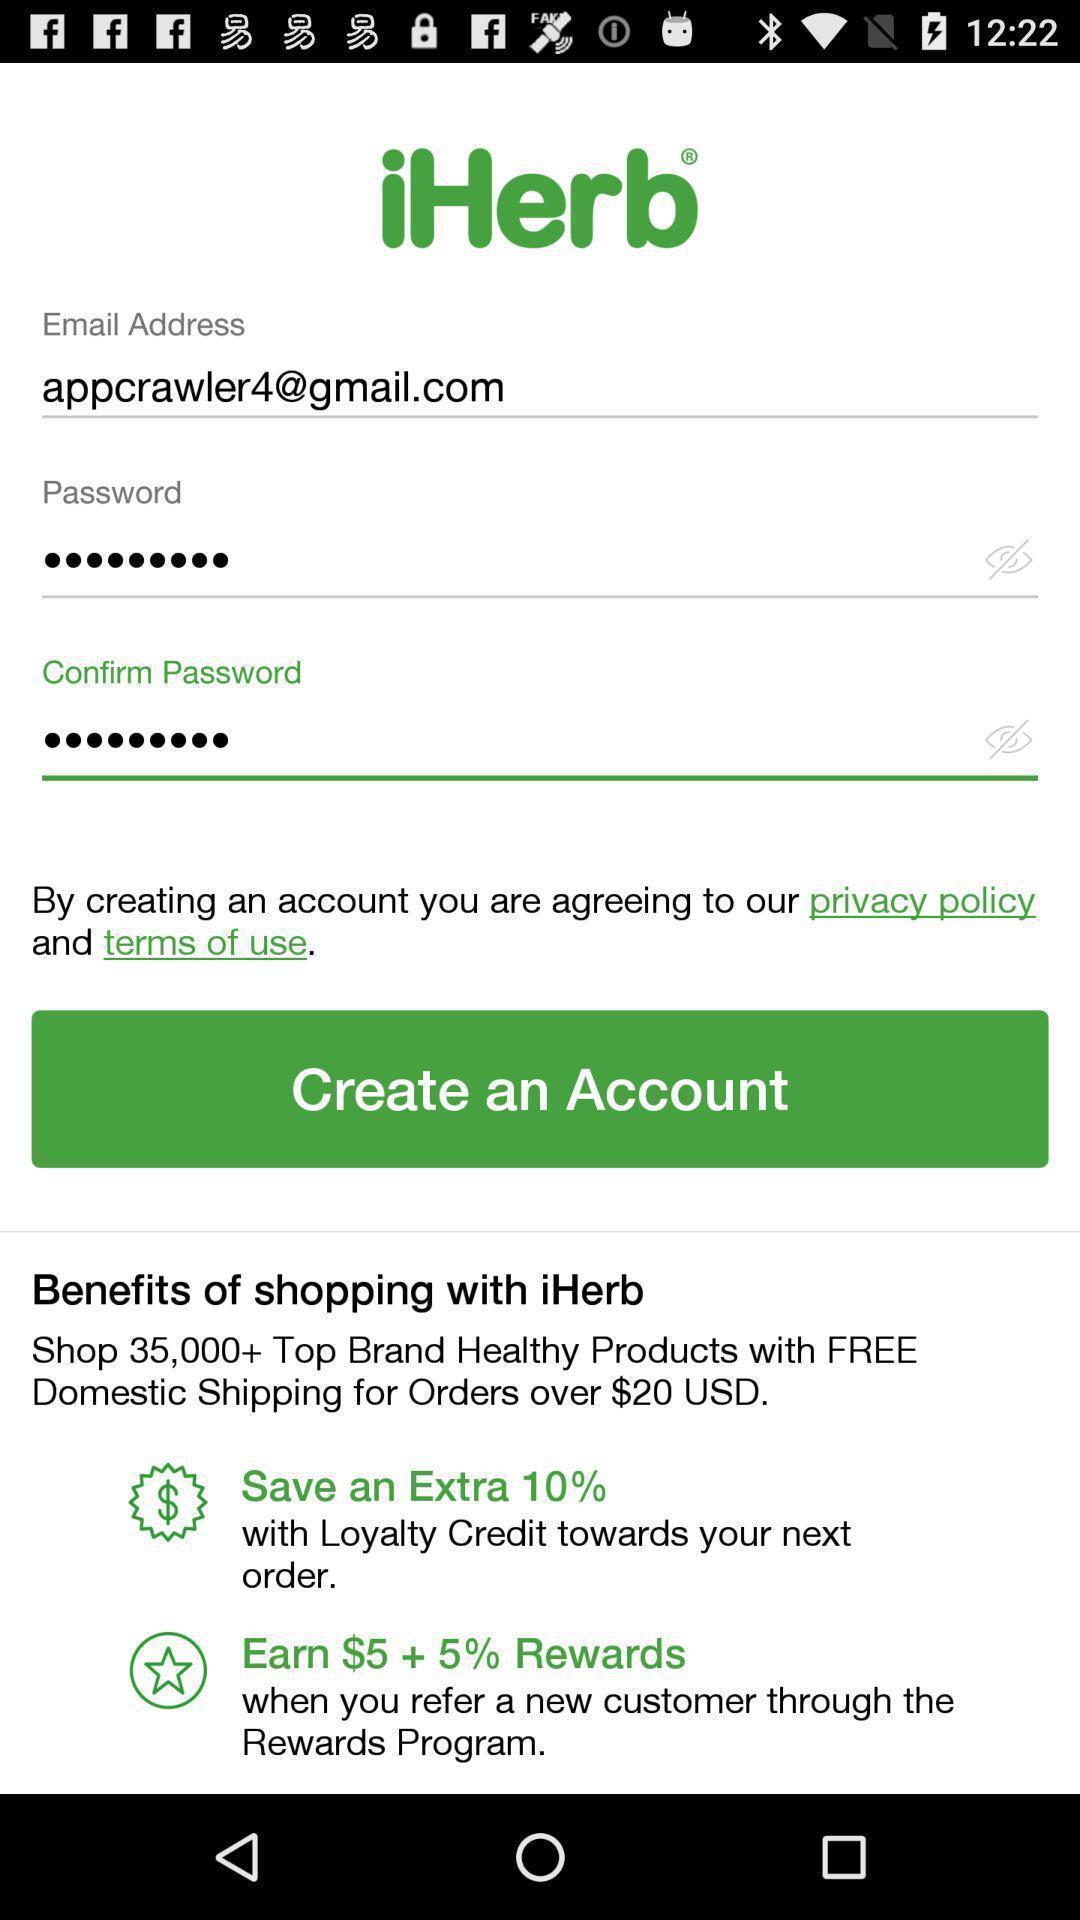What can you discern from this picture? Screen showing page to create an account. 